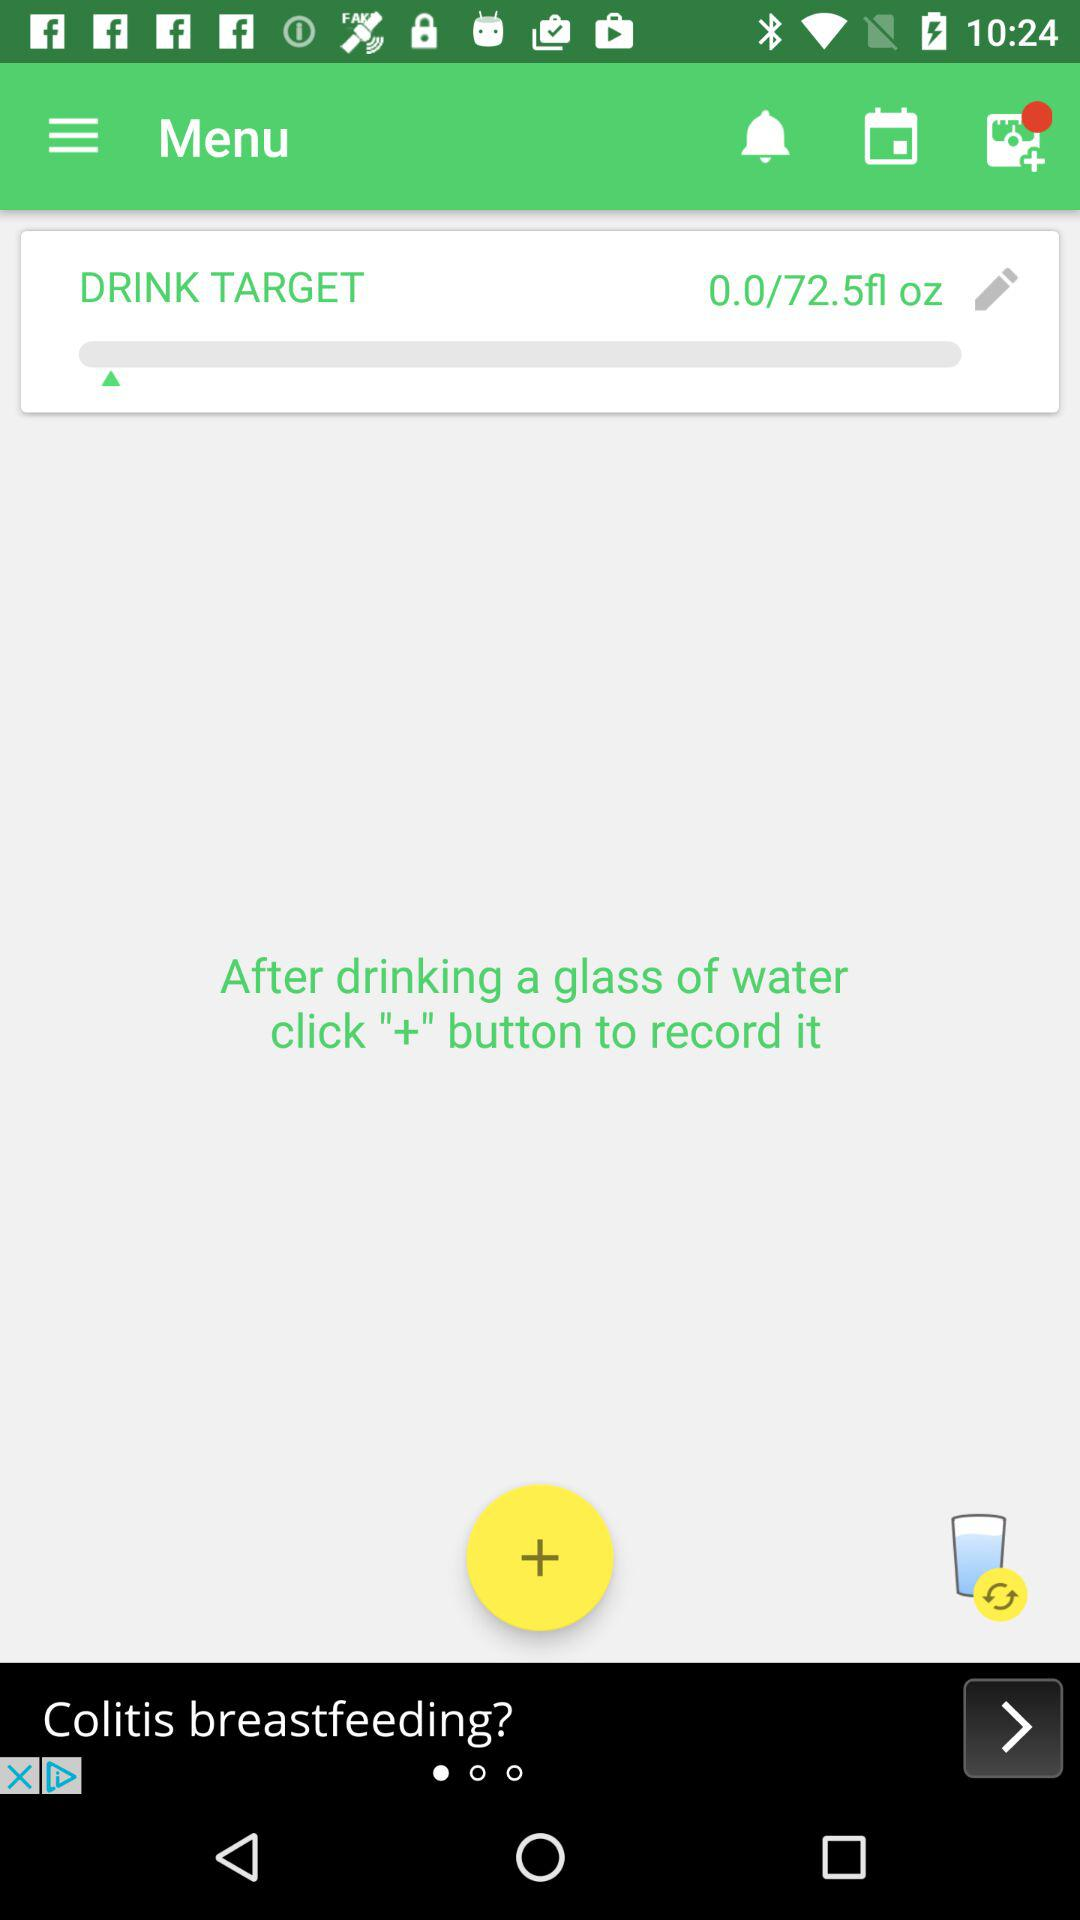How many drinks have I recorded so far?
Answer the question using a single word or phrase. 0 